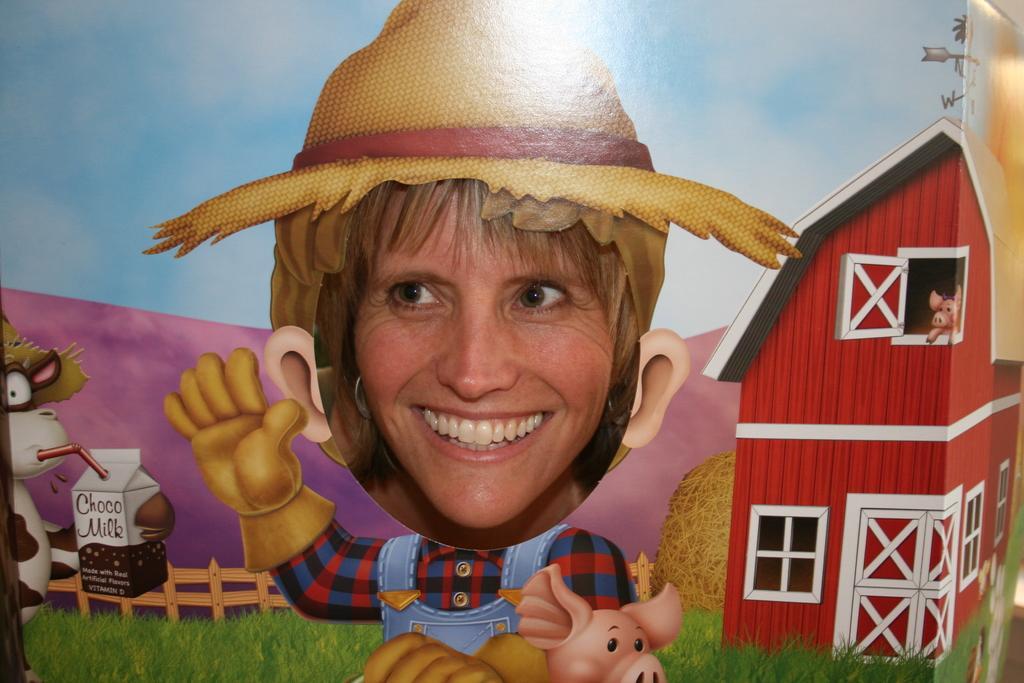Describe this image in one or two sentences. Here we can see a woman and she is smiling. Around this woman we can see an animated picture. Here we can see a house, grass, fence, box, and cartoons. 